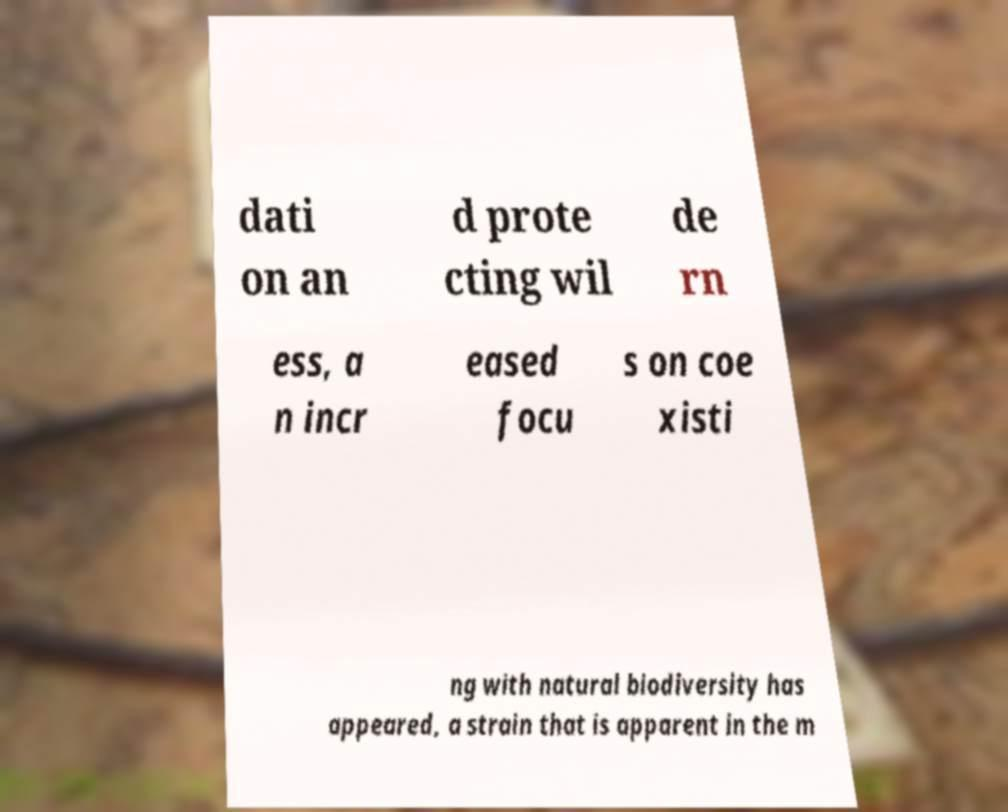Please read and relay the text visible in this image. What does it say? dati on an d prote cting wil de rn ess, a n incr eased focu s on coe xisti ng with natural biodiversity has appeared, a strain that is apparent in the m 